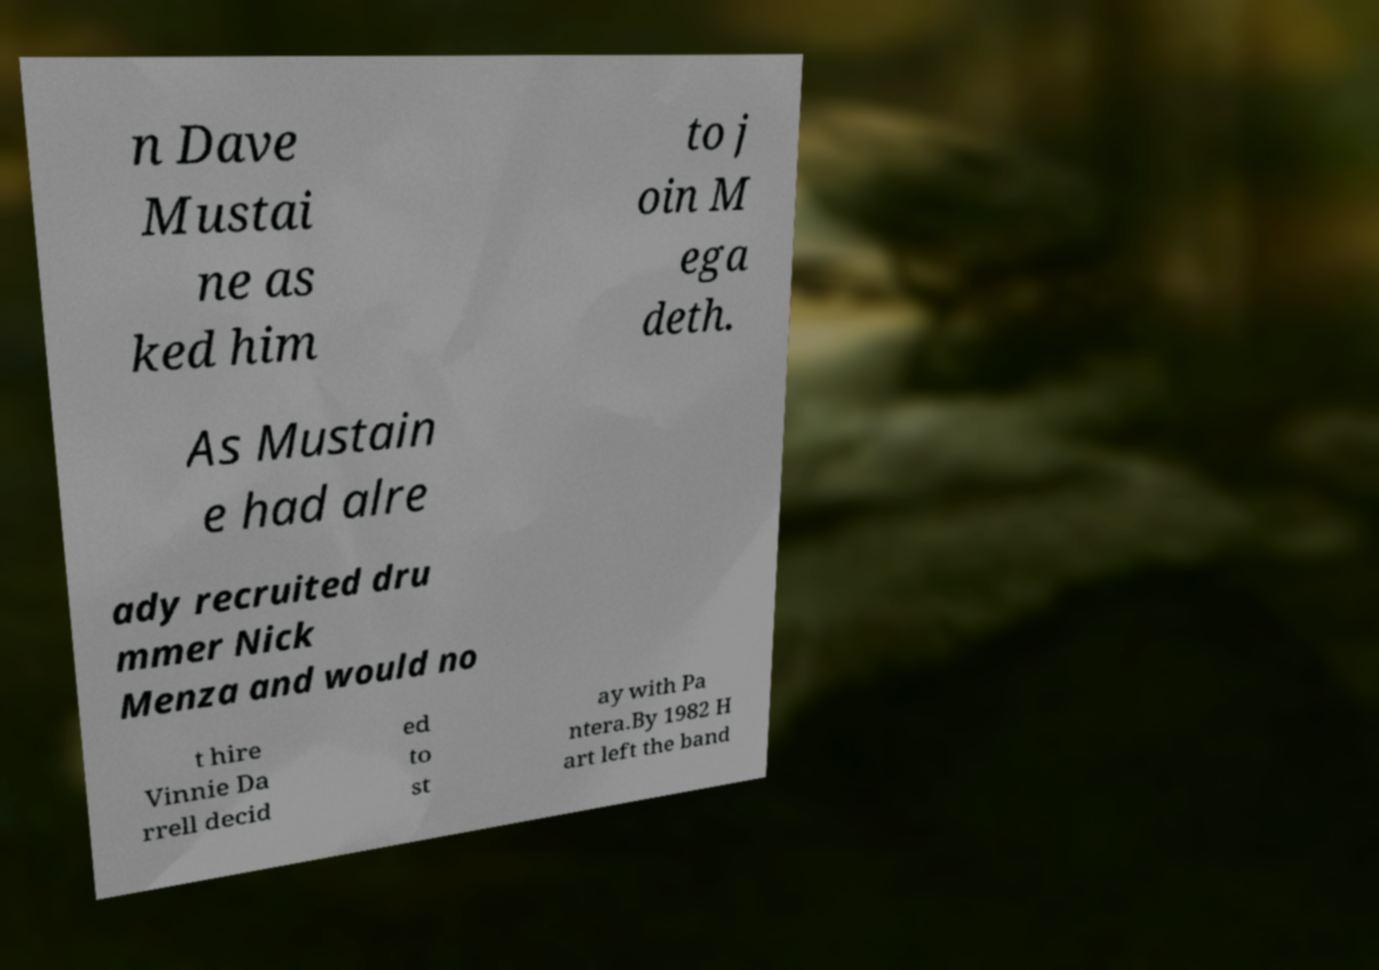For documentation purposes, I need the text within this image transcribed. Could you provide that? n Dave Mustai ne as ked him to j oin M ega deth. As Mustain e had alre ady recruited dru mmer Nick Menza and would no t hire Vinnie Da rrell decid ed to st ay with Pa ntera.By 1982 H art left the band 